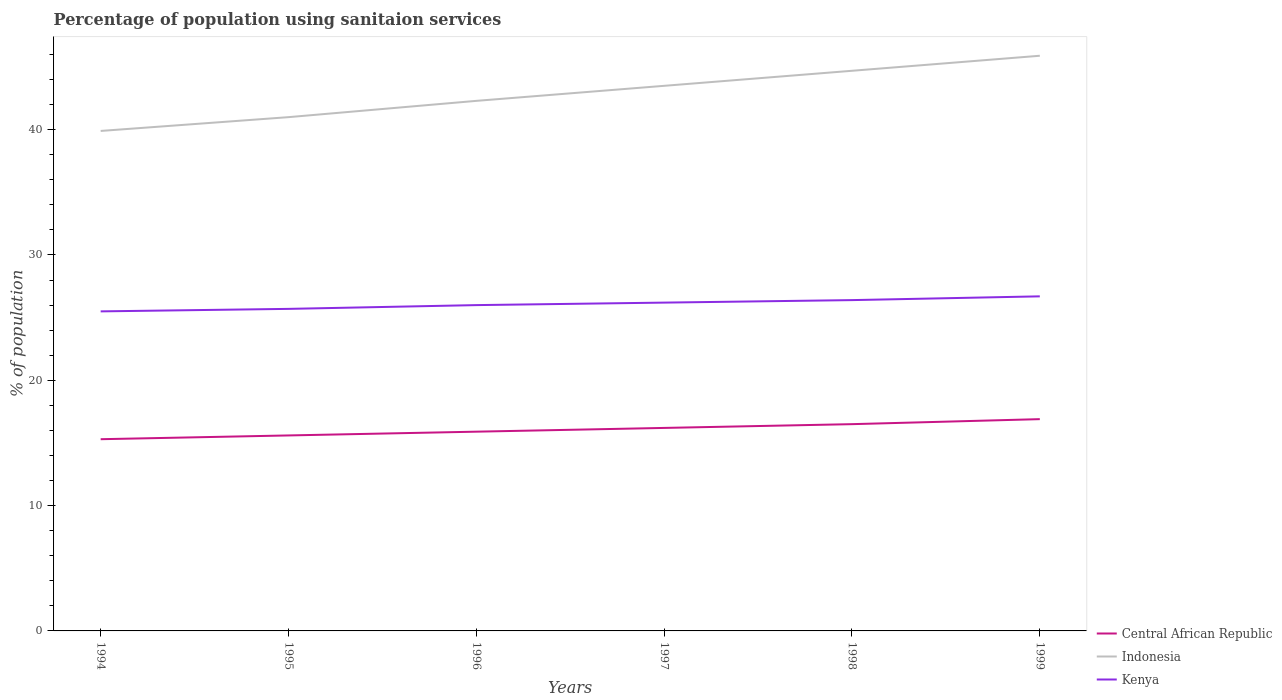How many different coloured lines are there?
Make the answer very short. 3. Across all years, what is the maximum percentage of population using sanitaion services in Kenya?
Keep it short and to the point. 25.5. In which year was the percentage of population using sanitaion services in Indonesia maximum?
Your answer should be very brief. 1994. What is the total percentage of population using sanitaion services in Central African Republic in the graph?
Your answer should be compact. -0.3. How many lines are there?
Keep it short and to the point. 3. Are the values on the major ticks of Y-axis written in scientific E-notation?
Give a very brief answer. No. Does the graph contain grids?
Offer a terse response. No. How many legend labels are there?
Offer a very short reply. 3. How are the legend labels stacked?
Your answer should be very brief. Vertical. What is the title of the graph?
Ensure brevity in your answer.  Percentage of population using sanitaion services. What is the label or title of the Y-axis?
Provide a succinct answer. % of population. What is the % of population in Central African Republic in 1994?
Keep it short and to the point. 15.3. What is the % of population of Indonesia in 1994?
Give a very brief answer. 39.9. What is the % of population in Central African Republic in 1995?
Give a very brief answer. 15.6. What is the % of population in Kenya in 1995?
Your answer should be very brief. 25.7. What is the % of population of Indonesia in 1996?
Make the answer very short. 42.3. What is the % of population in Kenya in 1996?
Keep it short and to the point. 26. What is the % of population in Indonesia in 1997?
Offer a very short reply. 43.5. What is the % of population of Kenya in 1997?
Offer a terse response. 26.2. What is the % of population in Indonesia in 1998?
Offer a very short reply. 44.7. What is the % of population in Kenya in 1998?
Keep it short and to the point. 26.4. What is the % of population in Indonesia in 1999?
Your answer should be compact. 45.9. What is the % of population of Kenya in 1999?
Give a very brief answer. 26.7. Across all years, what is the maximum % of population in Indonesia?
Give a very brief answer. 45.9. Across all years, what is the maximum % of population of Kenya?
Give a very brief answer. 26.7. Across all years, what is the minimum % of population of Indonesia?
Your response must be concise. 39.9. Across all years, what is the minimum % of population of Kenya?
Give a very brief answer. 25.5. What is the total % of population in Central African Republic in the graph?
Give a very brief answer. 96.4. What is the total % of population in Indonesia in the graph?
Offer a terse response. 257.3. What is the total % of population of Kenya in the graph?
Your response must be concise. 156.5. What is the difference between the % of population of Central African Republic in 1994 and that in 1995?
Keep it short and to the point. -0.3. What is the difference between the % of population in Kenya in 1994 and that in 1995?
Give a very brief answer. -0.2. What is the difference between the % of population in Indonesia in 1994 and that in 1996?
Your response must be concise. -2.4. What is the difference between the % of population in Kenya in 1994 and that in 1996?
Provide a succinct answer. -0.5. What is the difference between the % of population in Kenya in 1994 and that in 1997?
Provide a succinct answer. -0.7. What is the difference between the % of population of Indonesia in 1994 and that in 1999?
Your response must be concise. -6. What is the difference between the % of population of Central African Republic in 1995 and that in 1996?
Offer a terse response. -0.3. What is the difference between the % of population of Indonesia in 1995 and that in 1996?
Offer a very short reply. -1.3. What is the difference between the % of population of Kenya in 1995 and that in 1996?
Your answer should be very brief. -0.3. What is the difference between the % of population in Central African Republic in 1995 and that in 1997?
Provide a short and direct response. -0.6. What is the difference between the % of population of Indonesia in 1995 and that in 1997?
Ensure brevity in your answer.  -2.5. What is the difference between the % of population of Kenya in 1995 and that in 1997?
Provide a short and direct response. -0.5. What is the difference between the % of population of Central African Republic in 1995 and that in 1998?
Provide a succinct answer. -0.9. What is the difference between the % of population of Central African Republic in 1995 and that in 1999?
Keep it short and to the point. -1.3. What is the difference between the % of population of Indonesia in 1995 and that in 1999?
Your answer should be compact. -4.9. What is the difference between the % of population in Kenya in 1995 and that in 1999?
Keep it short and to the point. -1. What is the difference between the % of population of Indonesia in 1996 and that in 1999?
Give a very brief answer. -3.6. What is the difference between the % of population in Central African Republic in 1997 and that in 1998?
Give a very brief answer. -0.3. What is the difference between the % of population in Indonesia in 1997 and that in 1998?
Make the answer very short. -1.2. What is the difference between the % of population in Central African Republic in 1997 and that in 1999?
Your response must be concise. -0.7. What is the difference between the % of population of Indonesia in 1997 and that in 1999?
Make the answer very short. -2.4. What is the difference between the % of population of Kenya in 1997 and that in 1999?
Your response must be concise. -0.5. What is the difference between the % of population in Central African Republic in 1994 and the % of population in Indonesia in 1995?
Provide a short and direct response. -25.7. What is the difference between the % of population of Central African Republic in 1994 and the % of population of Kenya in 1995?
Provide a short and direct response. -10.4. What is the difference between the % of population in Central African Republic in 1994 and the % of population in Indonesia in 1996?
Make the answer very short. -27. What is the difference between the % of population of Central African Republic in 1994 and the % of population of Kenya in 1996?
Provide a short and direct response. -10.7. What is the difference between the % of population in Indonesia in 1994 and the % of population in Kenya in 1996?
Your answer should be compact. 13.9. What is the difference between the % of population of Central African Republic in 1994 and the % of population of Indonesia in 1997?
Provide a short and direct response. -28.2. What is the difference between the % of population of Central African Republic in 1994 and the % of population of Kenya in 1997?
Provide a short and direct response. -10.9. What is the difference between the % of population of Indonesia in 1994 and the % of population of Kenya in 1997?
Give a very brief answer. 13.7. What is the difference between the % of population in Central African Republic in 1994 and the % of population in Indonesia in 1998?
Make the answer very short. -29.4. What is the difference between the % of population in Central African Republic in 1994 and the % of population in Kenya in 1998?
Provide a short and direct response. -11.1. What is the difference between the % of population of Indonesia in 1994 and the % of population of Kenya in 1998?
Your answer should be very brief. 13.5. What is the difference between the % of population in Central African Republic in 1994 and the % of population in Indonesia in 1999?
Ensure brevity in your answer.  -30.6. What is the difference between the % of population in Central African Republic in 1995 and the % of population in Indonesia in 1996?
Provide a succinct answer. -26.7. What is the difference between the % of population in Central African Republic in 1995 and the % of population in Indonesia in 1997?
Ensure brevity in your answer.  -27.9. What is the difference between the % of population of Central African Republic in 1995 and the % of population of Kenya in 1997?
Provide a short and direct response. -10.6. What is the difference between the % of population in Central African Republic in 1995 and the % of population in Indonesia in 1998?
Provide a succinct answer. -29.1. What is the difference between the % of population in Indonesia in 1995 and the % of population in Kenya in 1998?
Provide a short and direct response. 14.6. What is the difference between the % of population in Central African Republic in 1995 and the % of population in Indonesia in 1999?
Provide a succinct answer. -30.3. What is the difference between the % of population in Central African Republic in 1995 and the % of population in Kenya in 1999?
Provide a succinct answer. -11.1. What is the difference between the % of population of Central African Republic in 1996 and the % of population of Indonesia in 1997?
Offer a terse response. -27.6. What is the difference between the % of population of Central African Republic in 1996 and the % of population of Kenya in 1997?
Your answer should be compact. -10.3. What is the difference between the % of population in Indonesia in 1996 and the % of population in Kenya in 1997?
Your answer should be compact. 16.1. What is the difference between the % of population of Central African Republic in 1996 and the % of population of Indonesia in 1998?
Give a very brief answer. -28.8. What is the difference between the % of population of Central African Republic in 1997 and the % of population of Indonesia in 1998?
Give a very brief answer. -28.5. What is the difference between the % of population in Central African Republic in 1997 and the % of population in Kenya in 1998?
Offer a very short reply. -10.2. What is the difference between the % of population of Central African Republic in 1997 and the % of population of Indonesia in 1999?
Make the answer very short. -29.7. What is the difference between the % of population of Central African Republic in 1998 and the % of population of Indonesia in 1999?
Your answer should be compact. -29.4. What is the difference between the % of population in Indonesia in 1998 and the % of population in Kenya in 1999?
Make the answer very short. 18. What is the average % of population of Central African Republic per year?
Give a very brief answer. 16.07. What is the average % of population of Indonesia per year?
Ensure brevity in your answer.  42.88. What is the average % of population in Kenya per year?
Provide a succinct answer. 26.08. In the year 1994, what is the difference between the % of population of Central African Republic and % of population of Indonesia?
Offer a terse response. -24.6. In the year 1995, what is the difference between the % of population of Central African Republic and % of population of Indonesia?
Your response must be concise. -25.4. In the year 1995, what is the difference between the % of population of Central African Republic and % of population of Kenya?
Give a very brief answer. -10.1. In the year 1996, what is the difference between the % of population in Central African Republic and % of population in Indonesia?
Make the answer very short. -26.4. In the year 1996, what is the difference between the % of population in Indonesia and % of population in Kenya?
Offer a very short reply. 16.3. In the year 1997, what is the difference between the % of population in Central African Republic and % of population in Indonesia?
Provide a succinct answer. -27.3. In the year 1997, what is the difference between the % of population in Central African Republic and % of population in Kenya?
Ensure brevity in your answer.  -10. In the year 1998, what is the difference between the % of population in Central African Republic and % of population in Indonesia?
Keep it short and to the point. -28.2. In the year 1999, what is the difference between the % of population in Central African Republic and % of population in Indonesia?
Keep it short and to the point. -29. In the year 1999, what is the difference between the % of population of Indonesia and % of population of Kenya?
Your answer should be very brief. 19.2. What is the ratio of the % of population of Central African Republic in 1994 to that in 1995?
Your response must be concise. 0.98. What is the ratio of the % of population of Indonesia in 1994 to that in 1995?
Offer a terse response. 0.97. What is the ratio of the % of population of Central African Republic in 1994 to that in 1996?
Offer a very short reply. 0.96. What is the ratio of the % of population of Indonesia in 1994 to that in 1996?
Your answer should be compact. 0.94. What is the ratio of the % of population in Kenya in 1994 to that in 1996?
Ensure brevity in your answer.  0.98. What is the ratio of the % of population in Central African Republic in 1994 to that in 1997?
Your response must be concise. 0.94. What is the ratio of the % of population of Indonesia in 1994 to that in 1997?
Your answer should be compact. 0.92. What is the ratio of the % of population of Kenya in 1994 to that in 1997?
Give a very brief answer. 0.97. What is the ratio of the % of population of Central African Republic in 1994 to that in 1998?
Make the answer very short. 0.93. What is the ratio of the % of population in Indonesia in 1994 to that in 1998?
Your answer should be very brief. 0.89. What is the ratio of the % of population in Kenya in 1994 to that in 1998?
Your answer should be very brief. 0.97. What is the ratio of the % of population in Central African Republic in 1994 to that in 1999?
Keep it short and to the point. 0.91. What is the ratio of the % of population in Indonesia in 1994 to that in 1999?
Provide a short and direct response. 0.87. What is the ratio of the % of population in Kenya in 1994 to that in 1999?
Give a very brief answer. 0.96. What is the ratio of the % of population of Central African Republic in 1995 to that in 1996?
Offer a very short reply. 0.98. What is the ratio of the % of population of Indonesia in 1995 to that in 1996?
Offer a terse response. 0.97. What is the ratio of the % of population in Kenya in 1995 to that in 1996?
Keep it short and to the point. 0.99. What is the ratio of the % of population in Central African Republic in 1995 to that in 1997?
Make the answer very short. 0.96. What is the ratio of the % of population in Indonesia in 1995 to that in 1997?
Offer a terse response. 0.94. What is the ratio of the % of population in Kenya in 1995 to that in 1997?
Offer a terse response. 0.98. What is the ratio of the % of population in Central African Republic in 1995 to that in 1998?
Your answer should be very brief. 0.95. What is the ratio of the % of population of Indonesia in 1995 to that in 1998?
Offer a very short reply. 0.92. What is the ratio of the % of population of Kenya in 1995 to that in 1998?
Offer a very short reply. 0.97. What is the ratio of the % of population in Indonesia in 1995 to that in 1999?
Provide a succinct answer. 0.89. What is the ratio of the % of population of Kenya in 1995 to that in 1999?
Ensure brevity in your answer.  0.96. What is the ratio of the % of population of Central African Republic in 1996 to that in 1997?
Your answer should be very brief. 0.98. What is the ratio of the % of population in Indonesia in 1996 to that in 1997?
Your response must be concise. 0.97. What is the ratio of the % of population in Central African Republic in 1996 to that in 1998?
Your answer should be compact. 0.96. What is the ratio of the % of population of Indonesia in 1996 to that in 1998?
Offer a terse response. 0.95. What is the ratio of the % of population in Central African Republic in 1996 to that in 1999?
Provide a short and direct response. 0.94. What is the ratio of the % of population in Indonesia in 1996 to that in 1999?
Your answer should be very brief. 0.92. What is the ratio of the % of population of Kenya in 1996 to that in 1999?
Keep it short and to the point. 0.97. What is the ratio of the % of population in Central African Republic in 1997 to that in 1998?
Keep it short and to the point. 0.98. What is the ratio of the % of population in Indonesia in 1997 to that in 1998?
Your answer should be very brief. 0.97. What is the ratio of the % of population of Central African Republic in 1997 to that in 1999?
Ensure brevity in your answer.  0.96. What is the ratio of the % of population in Indonesia in 1997 to that in 1999?
Give a very brief answer. 0.95. What is the ratio of the % of population of Kenya in 1997 to that in 1999?
Give a very brief answer. 0.98. What is the ratio of the % of population in Central African Republic in 1998 to that in 1999?
Your response must be concise. 0.98. What is the ratio of the % of population of Indonesia in 1998 to that in 1999?
Make the answer very short. 0.97. What is the difference between the highest and the lowest % of population in Central African Republic?
Provide a succinct answer. 1.6. What is the difference between the highest and the lowest % of population of Indonesia?
Your answer should be compact. 6. 